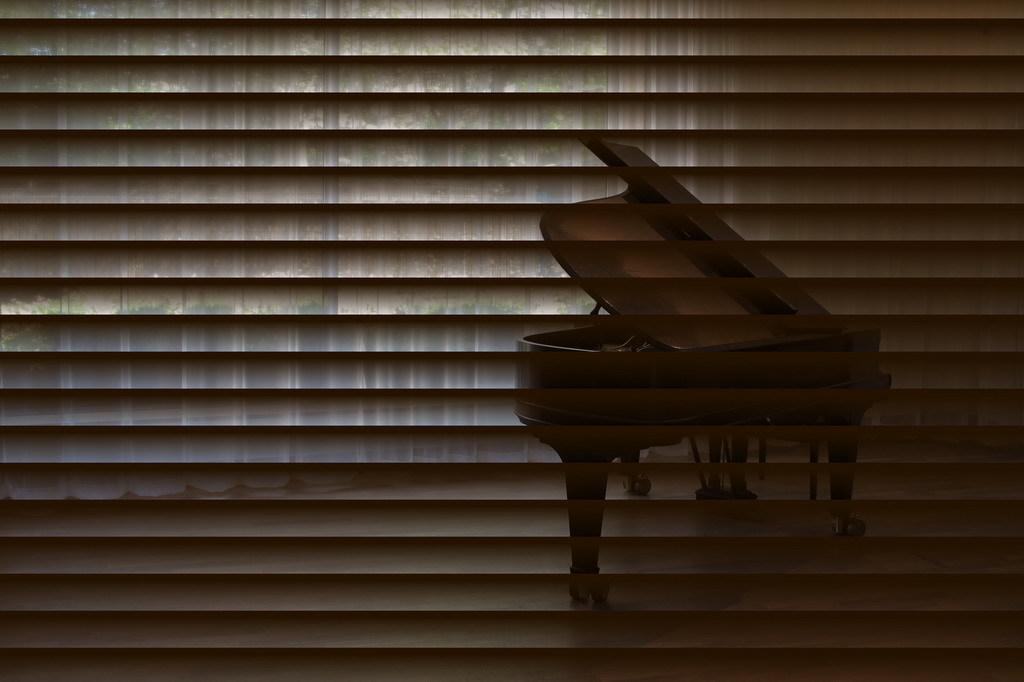What is located in the foreground of the image? There is a window blind in the foreground of the image. What can be seen through the window blind? A musical instrument is visible through the window blind. What type of wool is being used to play the musical instrument in the image? There is no wool present in the image, and the musical instrument is not being played. 